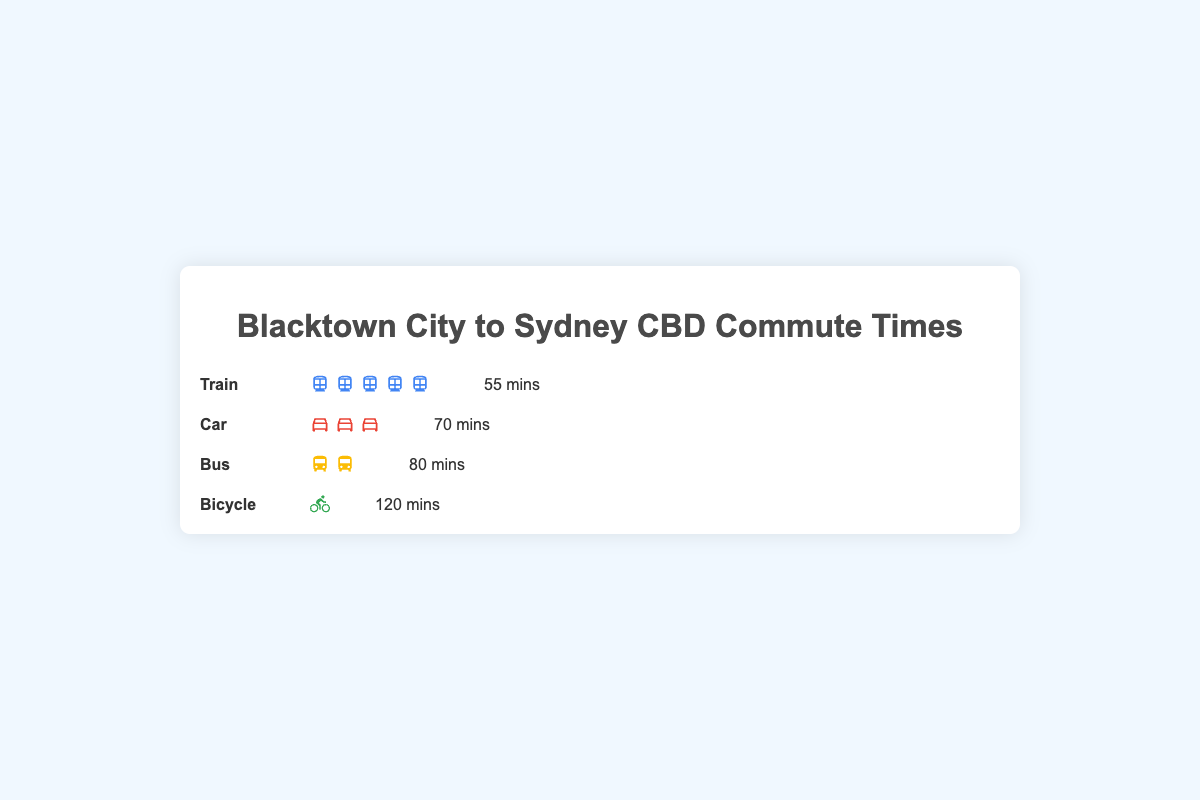What's the average commute time across all transportation methods? To find the average commute time, sum all commute times and divide by the number of methods. The commute times are 55 (Train), 70 (Car), 80 (Bus), and 120 (Bicycle). The sum is 55 + 70 + 80 + 120 = 325. There are 4 methods, so the average is 325/4 = 81.25
Answer: 81.25 mins Which transportation method has the shortest commute time? Just by looking at the figure, the transportation method with the lowest commute time, i.e., the smallest number indicated, is the Train with 55 minutes.
Answer: Train How many more minutes does it take to commute by bicycle compared to by bus? Subtract the commute time by bus from the commute time by bicycle. The commute time for the bus is 80 minutes and for the bicycle is 120 minutes, so 120 - 80 = 40 minutes.
Answer: 40 mins Which method of transportation is used by the most people? From the visual elements, the number of people is indicated by the number of icons. "Train" has 50 icons, which is the highest among all categories.
Answer: Train What is the total number of people represented in the figure? Sum the number of people for each method. Train has 50, Car has 30, Bus has 15, and Bicycle has 5. So, 50 + 30 + 15 + 5 = 100.
Answer: 100 people How does the commute time by car compare with the commute time by train? Simply compare the numbers, where car is 70 minutes and train is 55 minutes. Since 70 is greater than 55, commuting by car takes longer than by train.
Answer: Car commute time is longer What percent of people use bicycles to commute? Calculate the percentage by comparing the number of bicycle commuters to the total number of people. Bicycle has 5 people out of a total of 100, so (5/100) * 100% = 5%
Answer: 5% Which transportation method has the longest commute time? From the visual data, the longest commute time is represented, and it's for the Bicycle, which takes 120 minutes.
Answer: Bicycle If a new method of transportation is introduced with a commute time of 45 minutes, how would this affect the average commute time? First, calculate the current total commute time, which is 55 + 70 + 80 + 120 = 325 minutes. Adding the new method (45 minutes) gives 325 + 45 = 370 minutes. The total number of methods will be 5. The new average is 370/5 = 74 minutes.
Answer: 74 mins What is the difference in the number of people commuting by car and train? Subtract the number of car commuters from train commuters. Train has 50 people and car has 30 people, so 50 - 30 = 20 people.
Answer: 20 people 